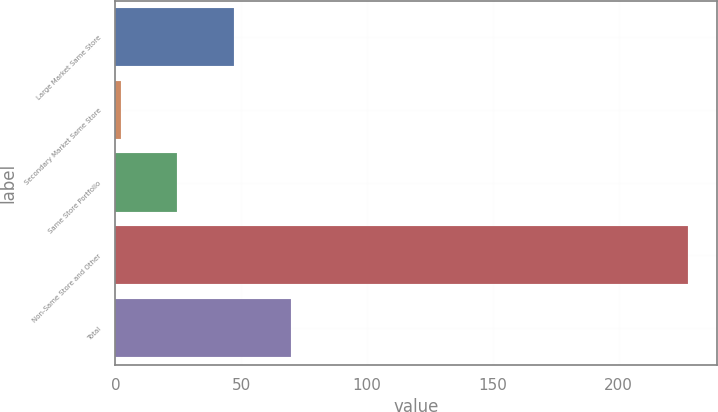Convert chart. <chart><loc_0><loc_0><loc_500><loc_500><bar_chart><fcel>Large Market Same Store<fcel>Secondary Market Same Store<fcel>Same Store Portfolio<fcel>Non-Same Store and Other<fcel>Total<nl><fcel>47.2<fcel>2.1<fcel>24.65<fcel>227.6<fcel>69.75<nl></chart> 